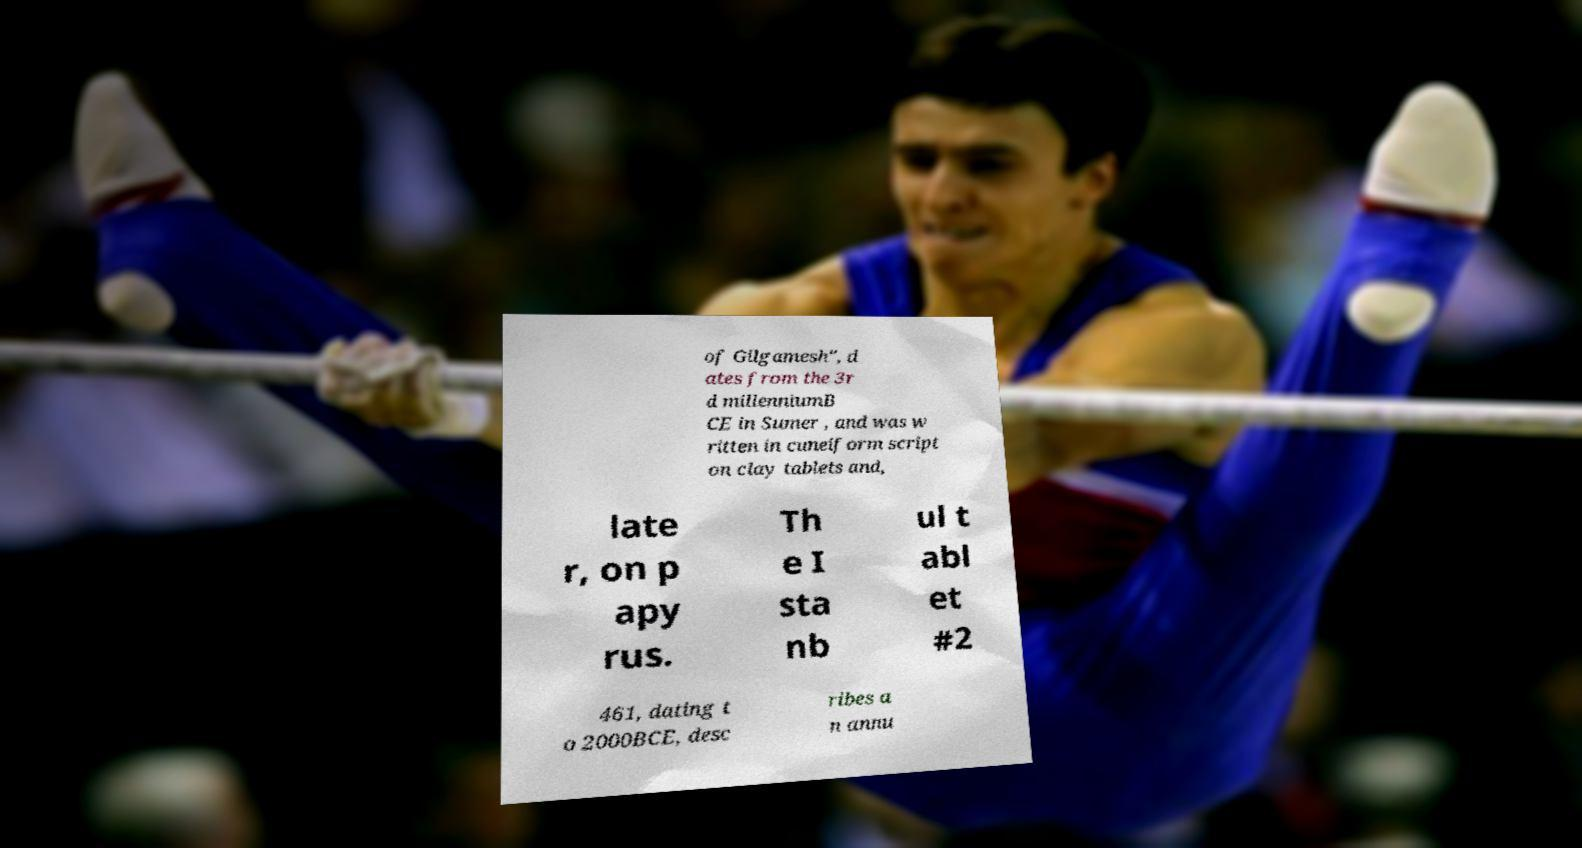Please identify and transcribe the text found in this image. of Gilgamesh", d ates from the 3r d millenniumB CE in Sumer , and was w ritten in cuneiform script on clay tablets and, late r, on p apy rus. Th e I sta nb ul t abl et #2 461, dating t o 2000BCE, desc ribes a n annu 